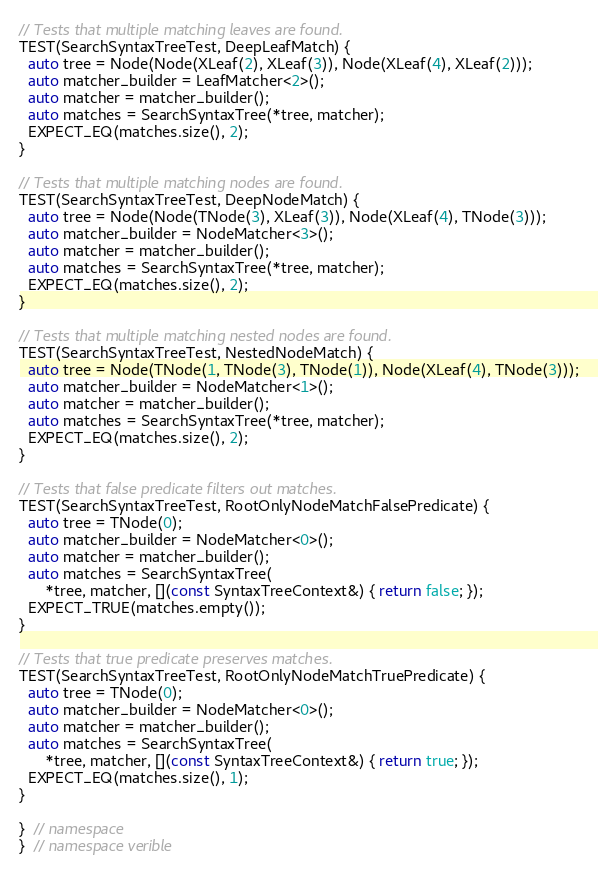<code> <loc_0><loc_0><loc_500><loc_500><_C++_>
// Tests that multiple matching leaves are found.
TEST(SearchSyntaxTreeTest, DeepLeafMatch) {
  auto tree = Node(Node(XLeaf(2), XLeaf(3)), Node(XLeaf(4), XLeaf(2)));
  auto matcher_builder = LeafMatcher<2>();
  auto matcher = matcher_builder();
  auto matches = SearchSyntaxTree(*tree, matcher);
  EXPECT_EQ(matches.size(), 2);
}

// Tests that multiple matching nodes are found.
TEST(SearchSyntaxTreeTest, DeepNodeMatch) {
  auto tree = Node(Node(TNode(3), XLeaf(3)), Node(XLeaf(4), TNode(3)));
  auto matcher_builder = NodeMatcher<3>();
  auto matcher = matcher_builder();
  auto matches = SearchSyntaxTree(*tree, matcher);
  EXPECT_EQ(matches.size(), 2);
}

// Tests that multiple matching nested nodes are found.
TEST(SearchSyntaxTreeTest, NestedNodeMatch) {
  auto tree = Node(TNode(1, TNode(3), TNode(1)), Node(XLeaf(4), TNode(3)));
  auto matcher_builder = NodeMatcher<1>();
  auto matcher = matcher_builder();
  auto matches = SearchSyntaxTree(*tree, matcher);
  EXPECT_EQ(matches.size(), 2);
}

// Tests that false predicate filters out matches.
TEST(SearchSyntaxTreeTest, RootOnlyNodeMatchFalsePredicate) {
  auto tree = TNode(0);
  auto matcher_builder = NodeMatcher<0>();
  auto matcher = matcher_builder();
  auto matches = SearchSyntaxTree(
      *tree, matcher, [](const SyntaxTreeContext&) { return false; });
  EXPECT_TRUE(matches.empty());
}

// Tests that true predicate preserves matches.
TEST(SearchSyntaxTreeTest, RootOnlyNodeMatchTruePredicate) {
  auto tree = TNode(0);
  auto matcher_builder = NodeMatcher<0>();
  auto matcher = matcher_builder();
  auto matches = SearchSyntaxTree(
      *tree, matcher, [](const SyntaxTreeContext&) { return true; });
  EXPECT_EQ(matches.size(), 1);
}

}  // namespace
}  // namespace verible
</code> 